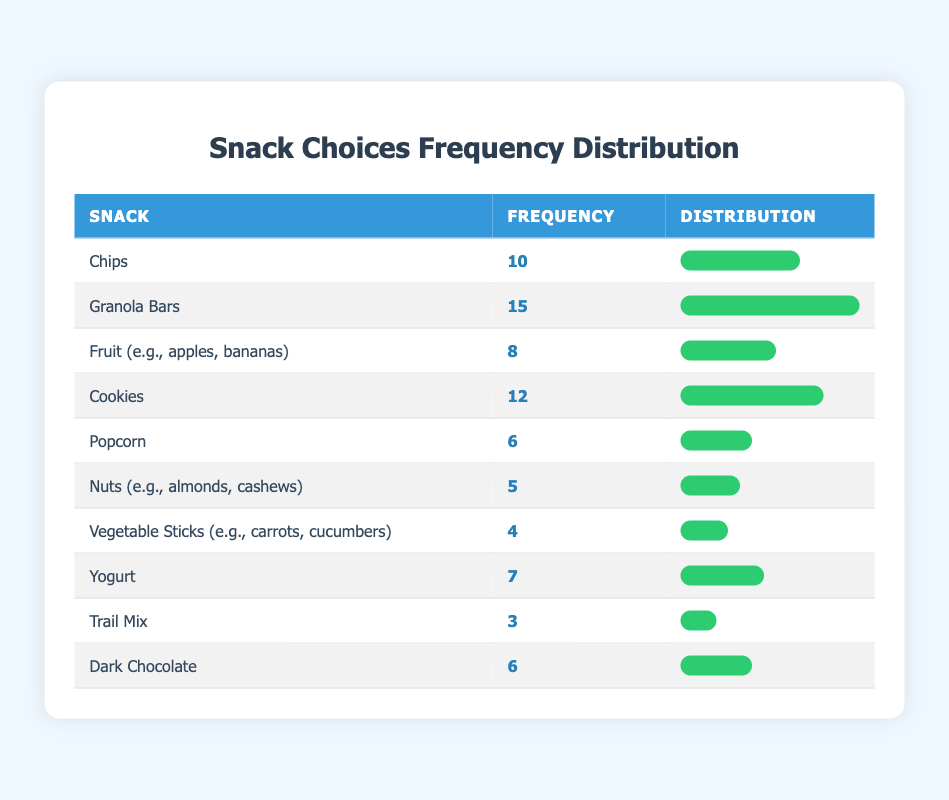What is the most popular snack choice? By looking at the frequency column, the snack with the highest frequency is "Granola Bars," which has a frequency of 15.
Answer: Granola Bars How many students chose Chips and Cookies combined? The frequency for Chips is 10 and for Cookies is 12. Summing these gives: 10 + 12 = 22.
Answer: 22 Is the frequency of Nuts greater than that of Vegetable Sticks? The frequency for Nuts is 5 and for Vegetable Sticks is 4. Since 5 > 4, the statement is true.
Answer: Yes What is the least popular snack choice based on frequency? The snack with the lowest frequency is "Trail Mix," which has a frequency of 3.
Answer: Trail Mix What is the average frequency of the snack choices listed? To find the average, add all frequencies: 10 + 15 + 8 + 12 + 6 + 5 + 4 + 7 + 3 + 6 = 66. There are 10 choices, so the average is 66 / 10 = 6.6.
Answer: 6.6 Which snack has a frequency closest to Yogurt? The frequency for Yogurt is 7. The closest frequency is for Cookies, which is 12, and Fruit, which is 8. Since 8 is closer to 7 than 12, the answer is Fruit.
Answer: Fruit Is it true that more people chose Granola Bars than Chips? Granola Bars has a frequency of 15 and Chips has a frequency of 10. Since 15 > 10, the statement is true.
Answer: Yes What percentage of students chose Popcorn compared to the total number of snack choices? Popcorn has a frequency of 6. The total frequency is 66. To find the percentage: (6 / 66) * 100 = 9.09%.
Answer: 9.09% 